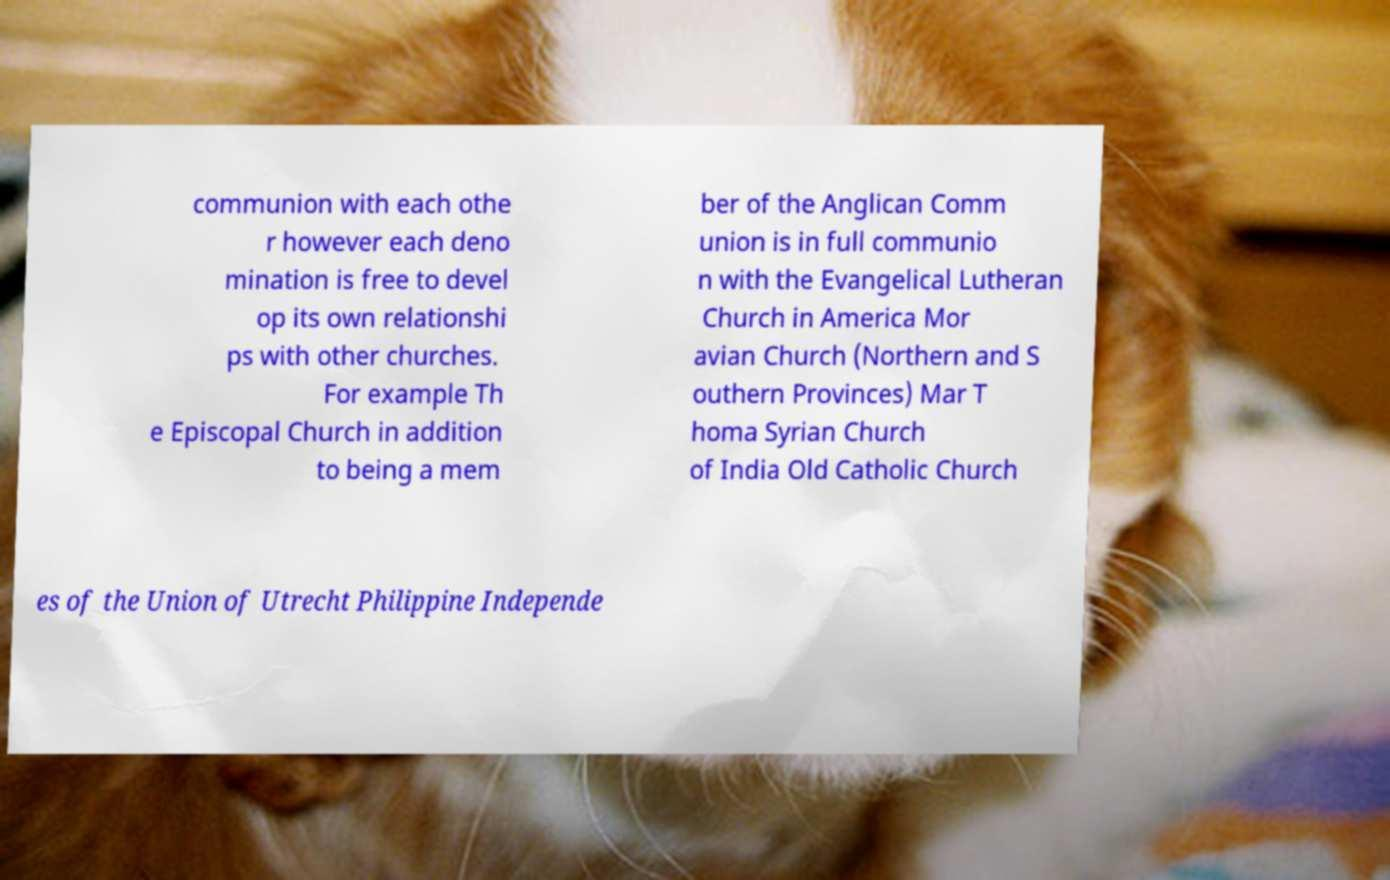Please identify and transcribe the text found in this image. communion with each othe r however each deno mination is free to devel op its own relationshi ps with other churches. For example Th e Episcopal Church in addition to being a mem ber of the Anglican Comm union is in full communio n with the Evangelical Lutheran Church in America Mor avian Church (Northern and S outhern Provinces) Mar T homa Syrian Church of India Old Catholic Church es of the Union of Utrecht Philippine Independe 